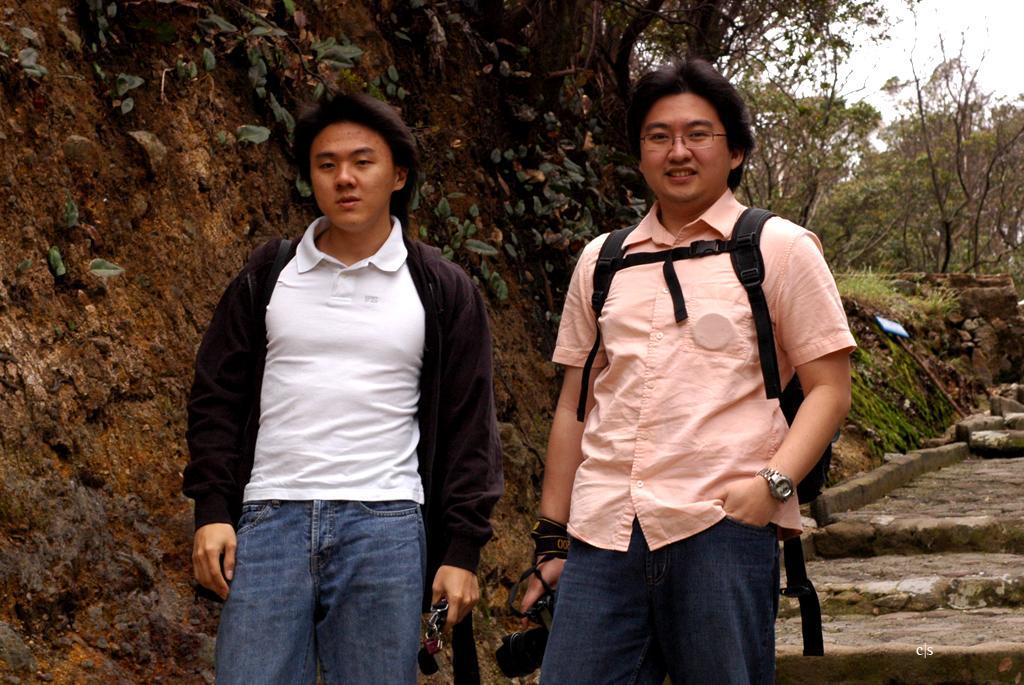Please provide a concise description of this image. In the center of the image we can see two persons are standing and they are smiling, which we can see on their faces. And they are holding some objects and they are wearing backpacks. In the background we can see the sky, trees, grass, one sign board, staircase etc. 